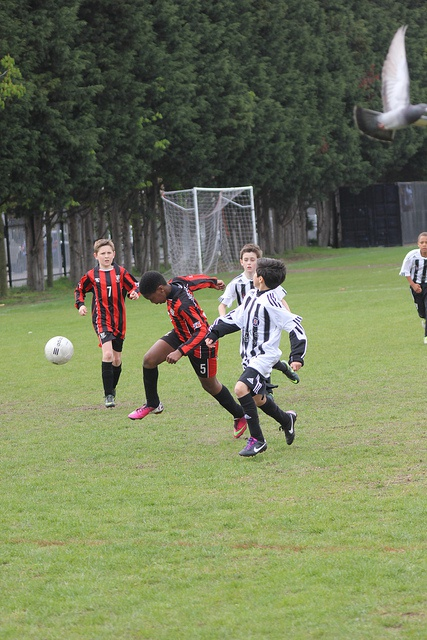Describe the objects in this image and their specific colors. I can see people in black, lavender, and gray tones, people in black, gray, maroon, and olive tones, people in black, gray, red, and salmon tones, bird in black, lavender, gray, and darkgray tones, and people in black, lavender, darkgray, pink, and gray tones in this image. 